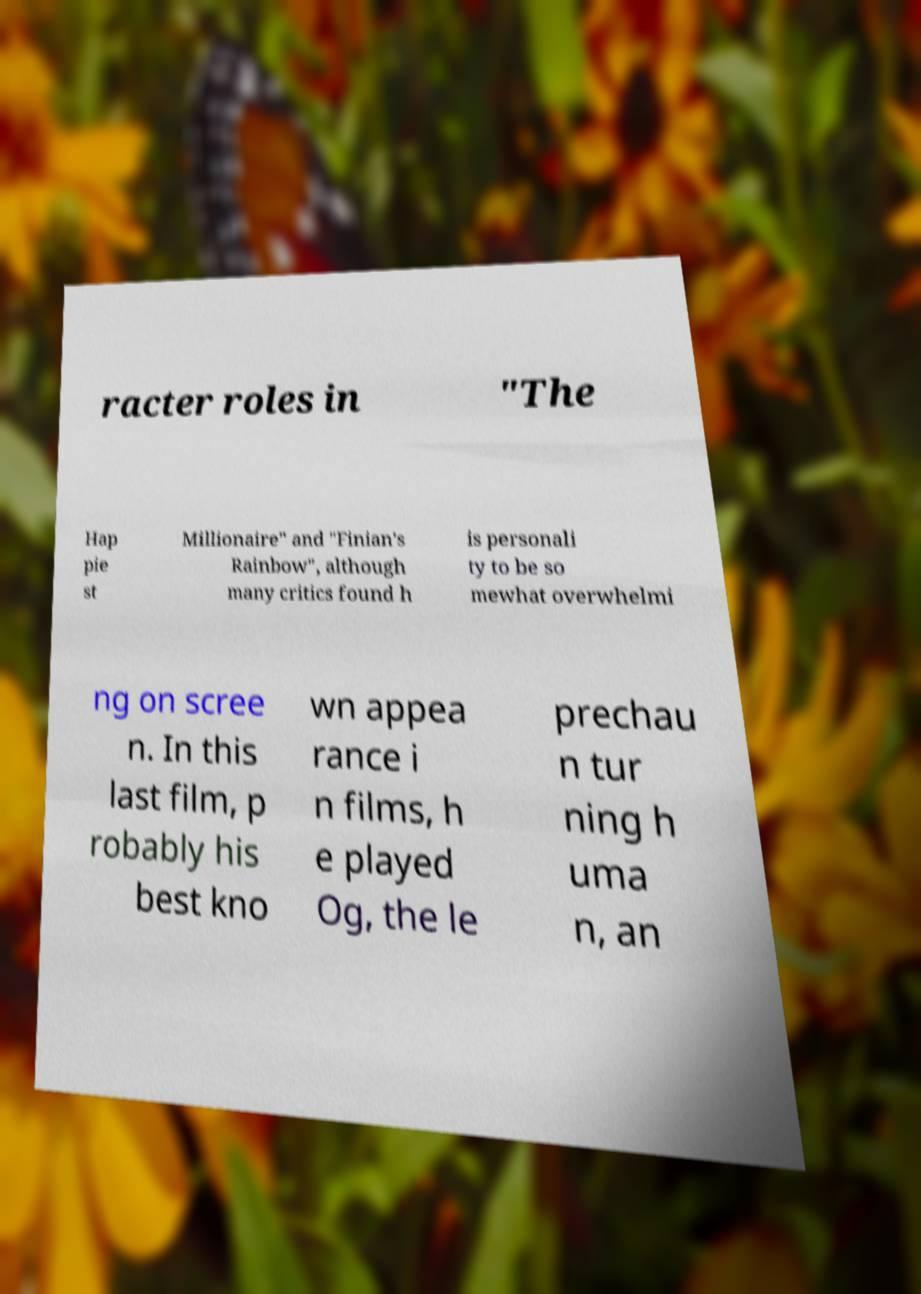Can you read and provide the text displayed in the image?This photo seems to have some interesting text. Can you extract and type it out for me? racter roles in "The Hap pie st Millionaire" and "Finian's Rainbow", although many critics found h is personali ty to be so mewhat overwhelmi ng on scree n. In this last film, p robably his best kno wn appea rance i n films, h e played Og, the le prechau n tur ning h uma n, an 